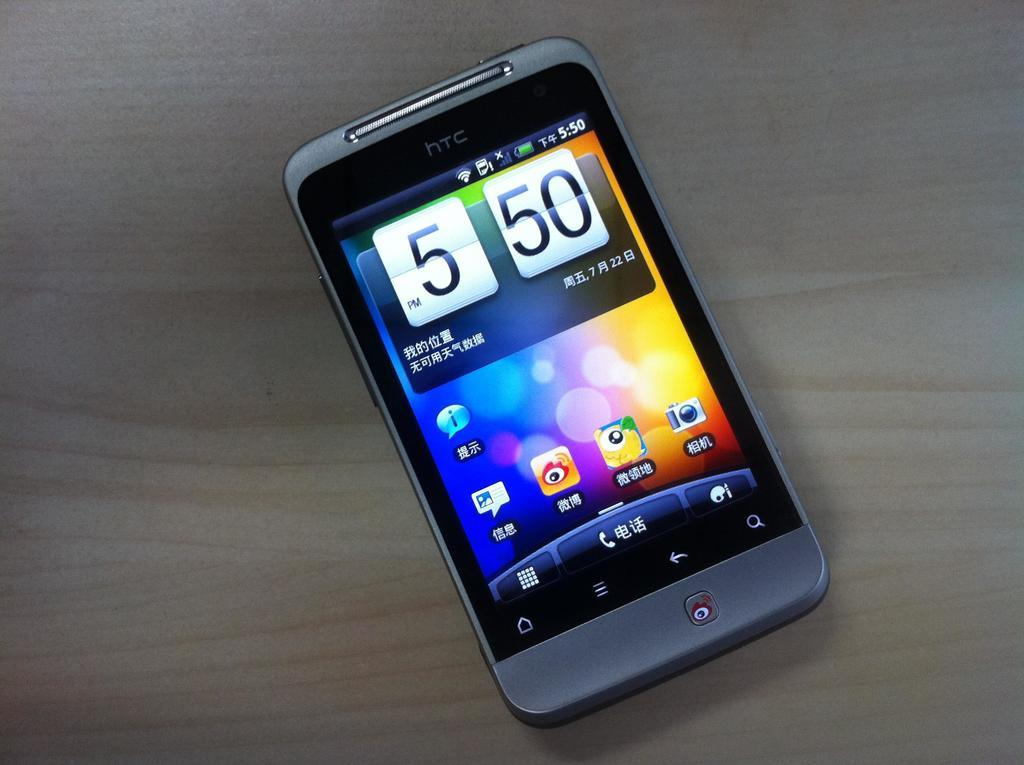<image>
Present a compact description of the photo's key features. A cell phone shows that it is 5:50 p.m. 